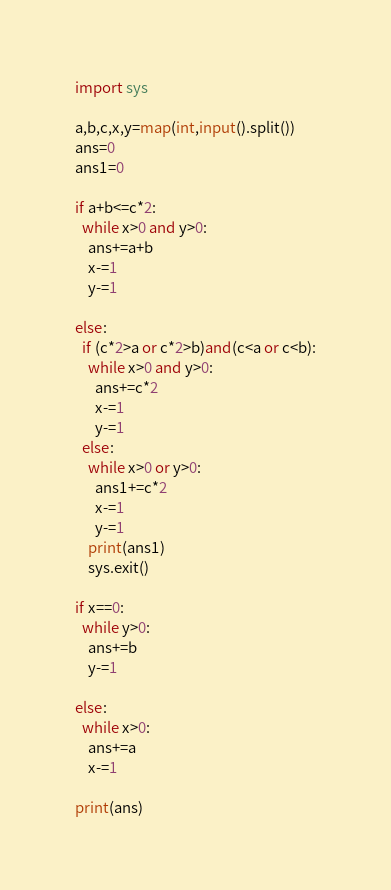Convert code to text. <code><loc_0><loc_0><loc_500><loc_500><_Python_>import sys

a,b,c,x,y=map(int,input().split())
ans=0
ans1=0

if a+b<=c*2:
  while x>0 and y>0:
    ans+=a+b
    x-=1
    y-=1

else:
  if (c*2>a or c*2>b)and(c<a or c<b):
    while x>0 and y>0:
      ans+=c*2
      x-=1
      y-=1
  else:
    while x>0 or y>0:
      ans1+=c*2
      x-=1
      y-=1
    print(ans1)
    sys.exit()

if x==0:
  while y>0:
    ans+=b
    y-=1

else:
  while x>0:
    ans+=a
    x-=1

print(ans)</code> 